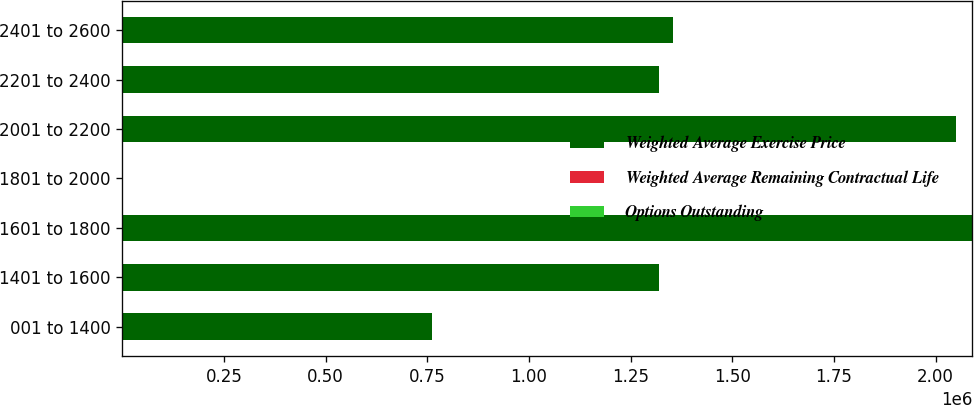Convert chart. <chart><loc_0><loc_0><loc_500><loc_500><stacked_bar_chart><ecel><fcel>001 to 1400<fcel>1401 to 1600<fcel>1601 to 1800<fcel>1801 to 2000<fcel>2001 to 2200<fcel>2201 to 2400<fcel>2401 to 2600<nl><fcel>Weighted Average Exercise Price<fcel>760756<fcel>1.31871e+06<fcel>2.09018e+06<fcel>18.05<fcel>2.05108e+06<fcel>1.31842e+06<fcel>1.35389e+06<nl><fcel>Weighted Average Remaining Contractual Life<fcel>4.13<fcel>2.87<fcel>3.19<fcel>3.94<fcel>6.79<fcel>6.84<fcel>9.05<nl><fcel>Options Outstanding<fcel>13.8<fcel>15.71<fcel>17.34<fcel>18.76<fcel>21.42<fcel>22.93<fcel>24.65<nl></chart> 